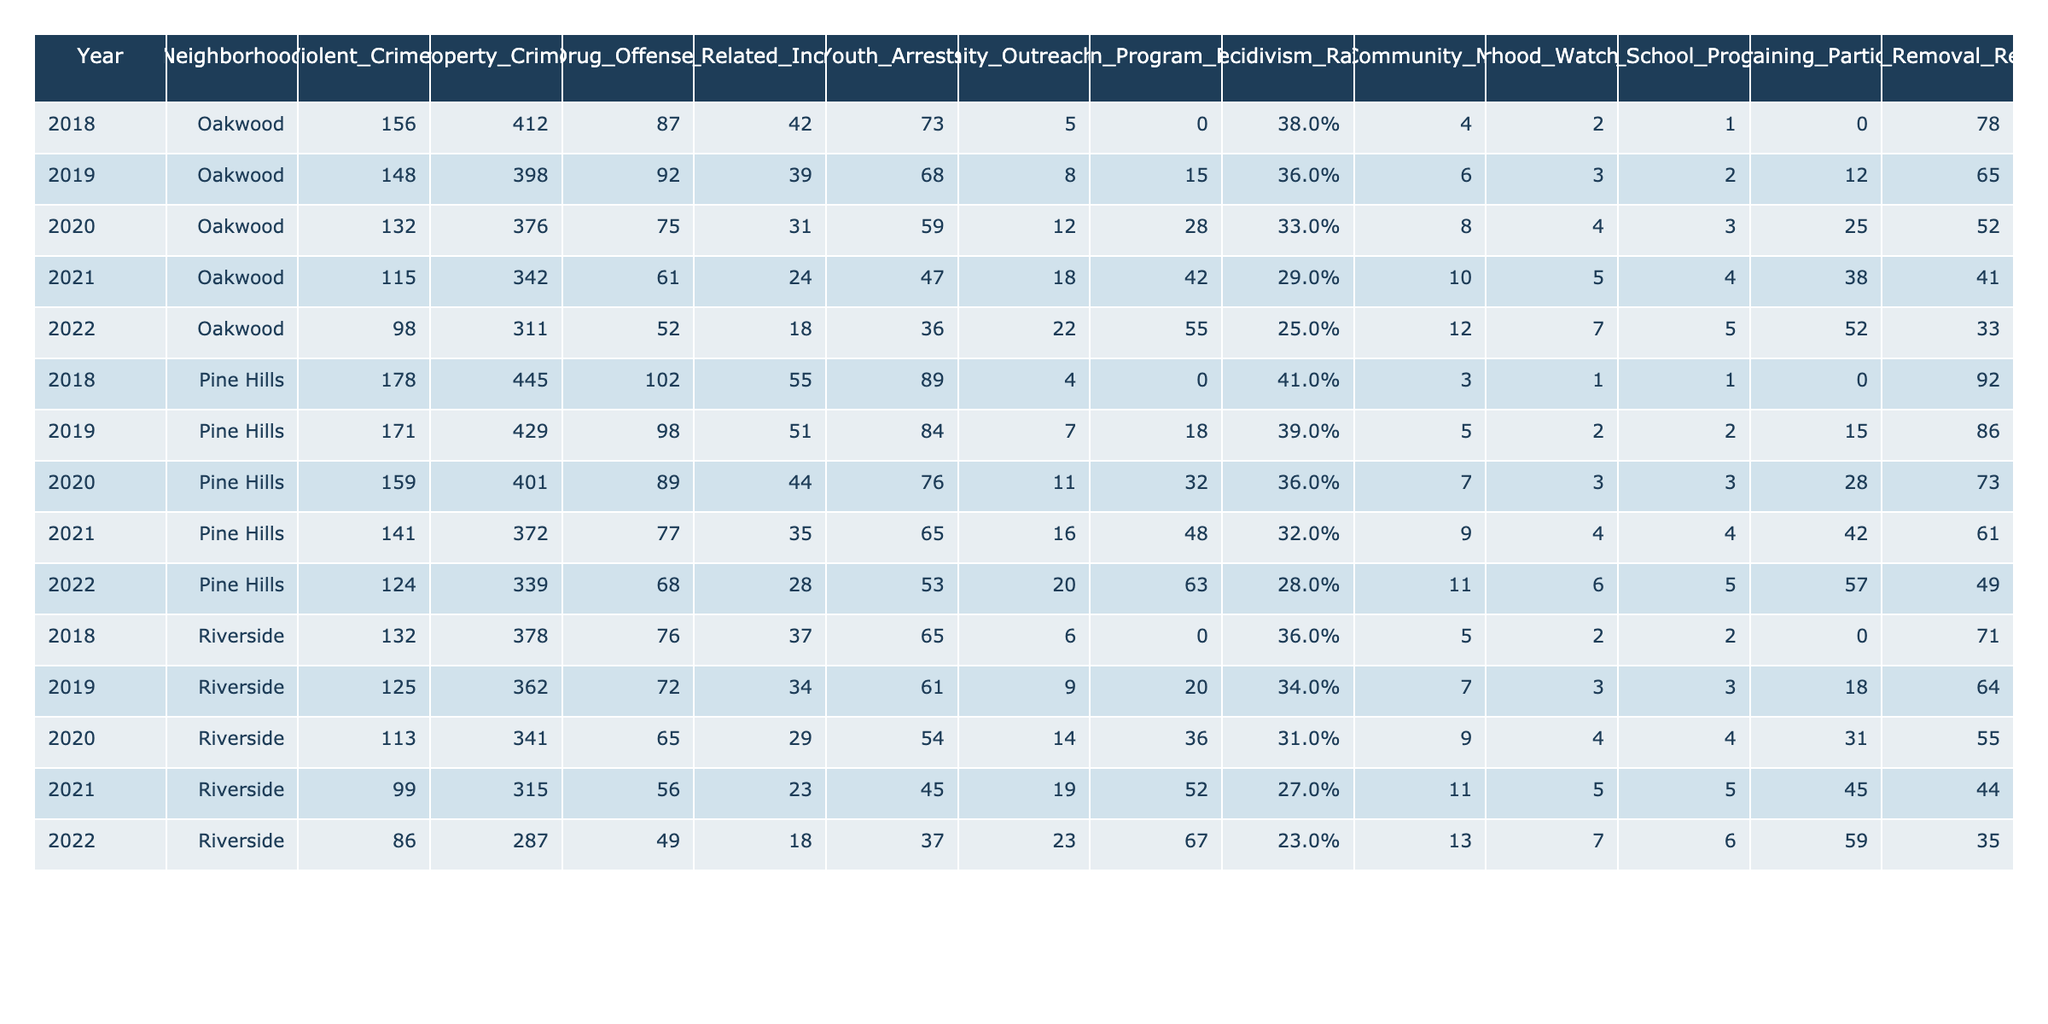What was the total number of gang-related incidents in Oakwood from 2018 to 2022? To find the total number of gang-related incidents in Oakwood, I sum the values for each year: 42 + 39 + 31 + 24 + 18 = 154.
Answer: 154 What is the recidivism rate in Pine Hills for the year 2022? The recidivism rate for Pine Hills in 2022 is already provided in the table as 28%.
Answer: 28% Which neighborhood had the highest number of violent crimes in 2020? In 2020, the number of violent crimes was 132 in Oakwood, 159 in Pine Hills, and 113 in Riverside. The highest value is 159 in Pine Hills.
Answer: Pine Hills What is the average number of property crimes in Riverside from 2018 to 2022? I add the property crimes for Riverside from 2018 to 2022: 378 + 362 + 341 + 315 + 287 = 1683. Then, I divide by the number of years (5): 1683 / 5 = 336.6, rounding down gives 336.
Answer: 336 Did Oakwood see a decrease in youth arrests from 2018 to 2022? In 2018, there were 73 youth arrests, which decreased to 36 by 2022. Since 36 is less than 73, this confirms a decrease.
Answer: Yes How many community outreach events were held in Pine Hills in 2020? The number of community outreach events held in Pine Hills in 2020 is explicitly stated in the table as 11.
Answer: 11 What is the difference in the number of job training participants between Oakwood and Pine Hills in 2021? In 2021, Oakwood had 38 job training participants, and Pine Hills had 42. The difference is calculated as 42 - 38 = 4.
Answer: 4 In which year did Riverside have the lowest recidivism rate? Reviewing the recidivism rates for Riverside from 2018 to 2022, the figures are 36%, 34%, 31%, 27%, and 23%, respectively. The lowest rate is 23% in 2022.
Answer: 2022 How many more graffiti removal requests were made in the year 2019 compared to 2020 in Oakwood? In 2019, there were 65 graffiti removal requests, while in 2020 there were 52 requests. The difference is 65 - 52 = 13.
Answer: 13 What is the trend in the number of after school programs offered in Oakwood from 2018 to 2022? From 2018 to 2022, the number of after school programs increased from 0 to 5. This shows a continuous increase over the years.
Answer: Continuous increase 